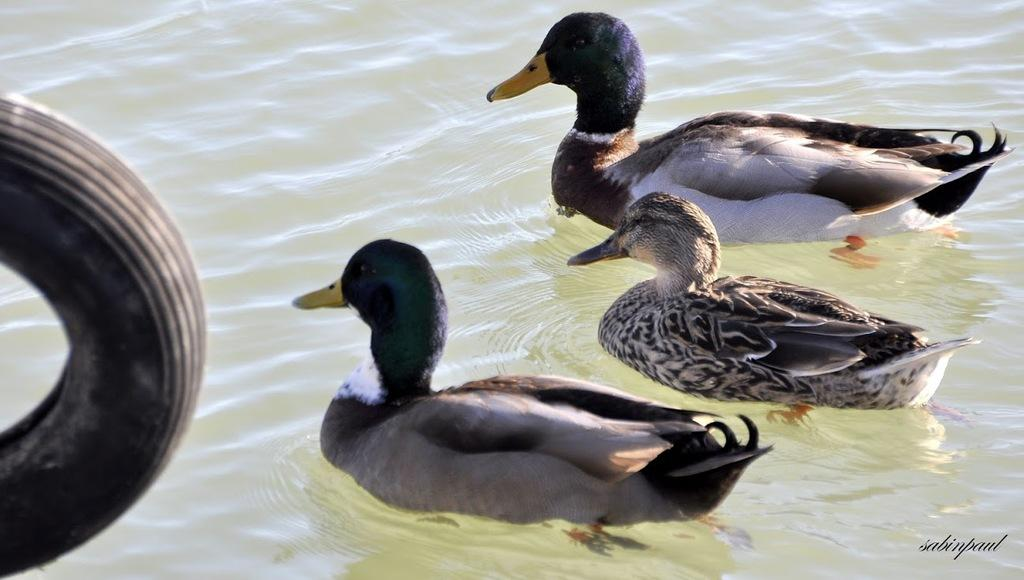How many ducks are in the image? There are three ducks in the image. Where are the ducks located? The ducks are on the water. What object can be seen on the left side of the image? There is a Tyre on the left side of the image. Is there a beggar asking for money near the ducks in the image? No, there is no beggar present in the image. What type of wind can be seen blowing the ducks around in the image? There is no wind, such as a zephyr, depicted in the image; the ducks are stationary on the water. 